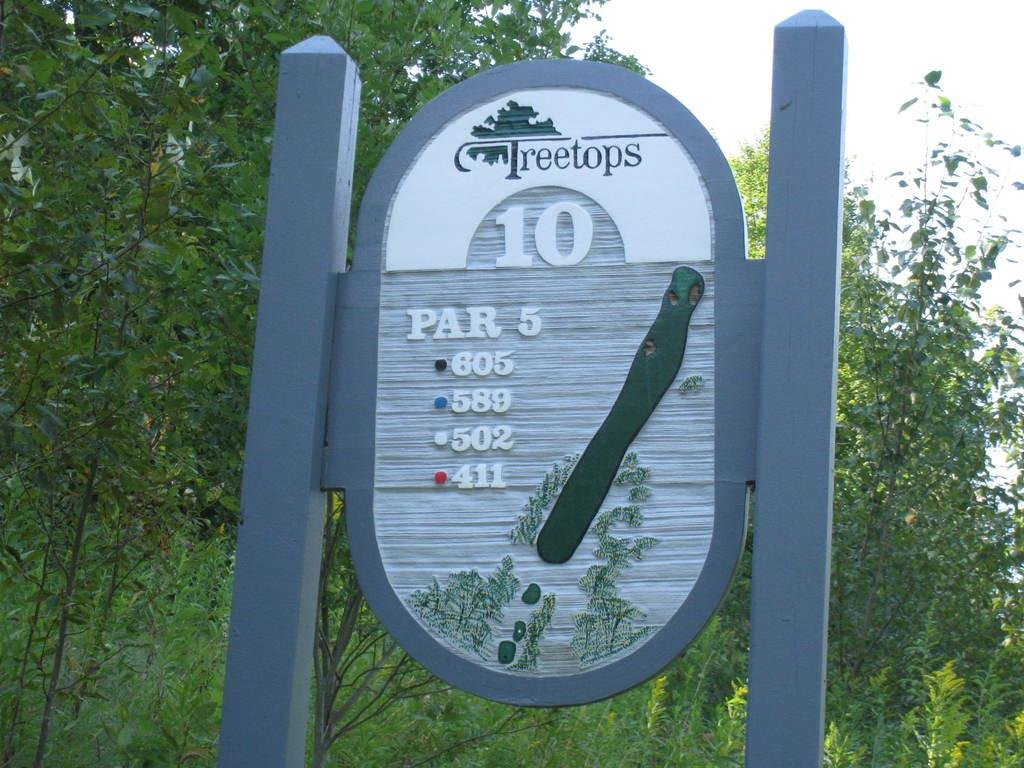What is on the pole in the image? There is a board on a pole in the image. What can be seen on the board? There is text and pictures of trees on the board. What is visible in the background of the image? There are trees visible in the background of the image. What is visible at the top of the image? The sky is visible at the top of the image. How many chairs are placed around the locket in the image? There is no locket or chairs present in the image. 